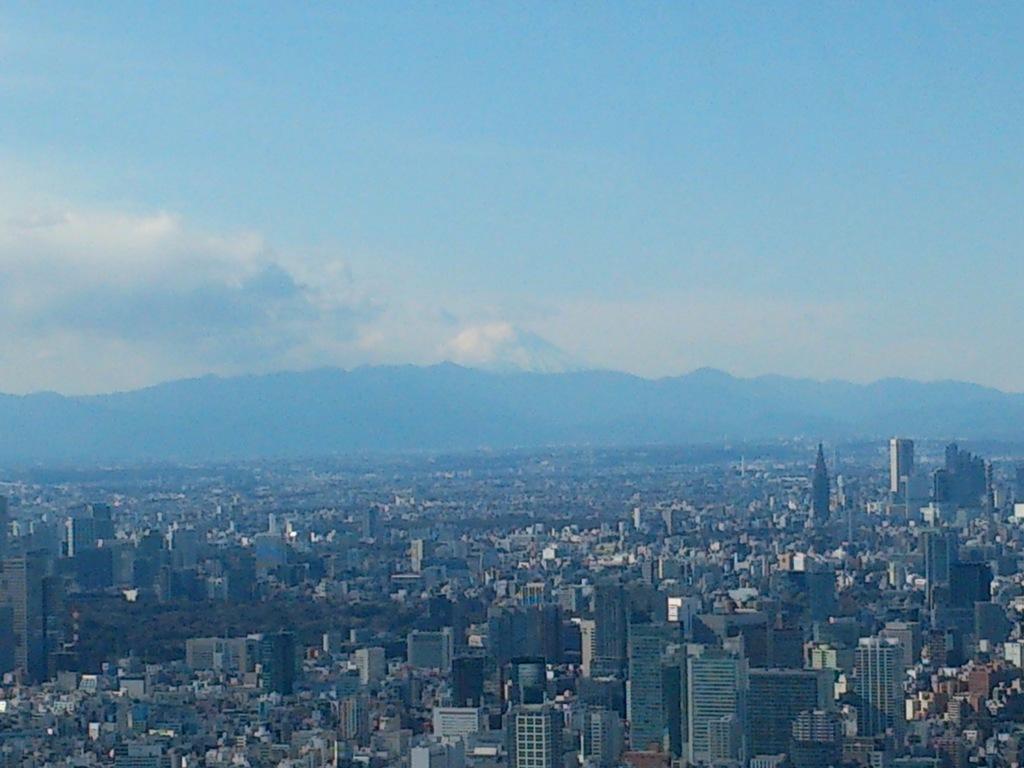Could you give a brief overview of what you see in this image? In this image there is an aerial view of the city, there are buildingś, houseś, treeś, there is a sky with clouds. 